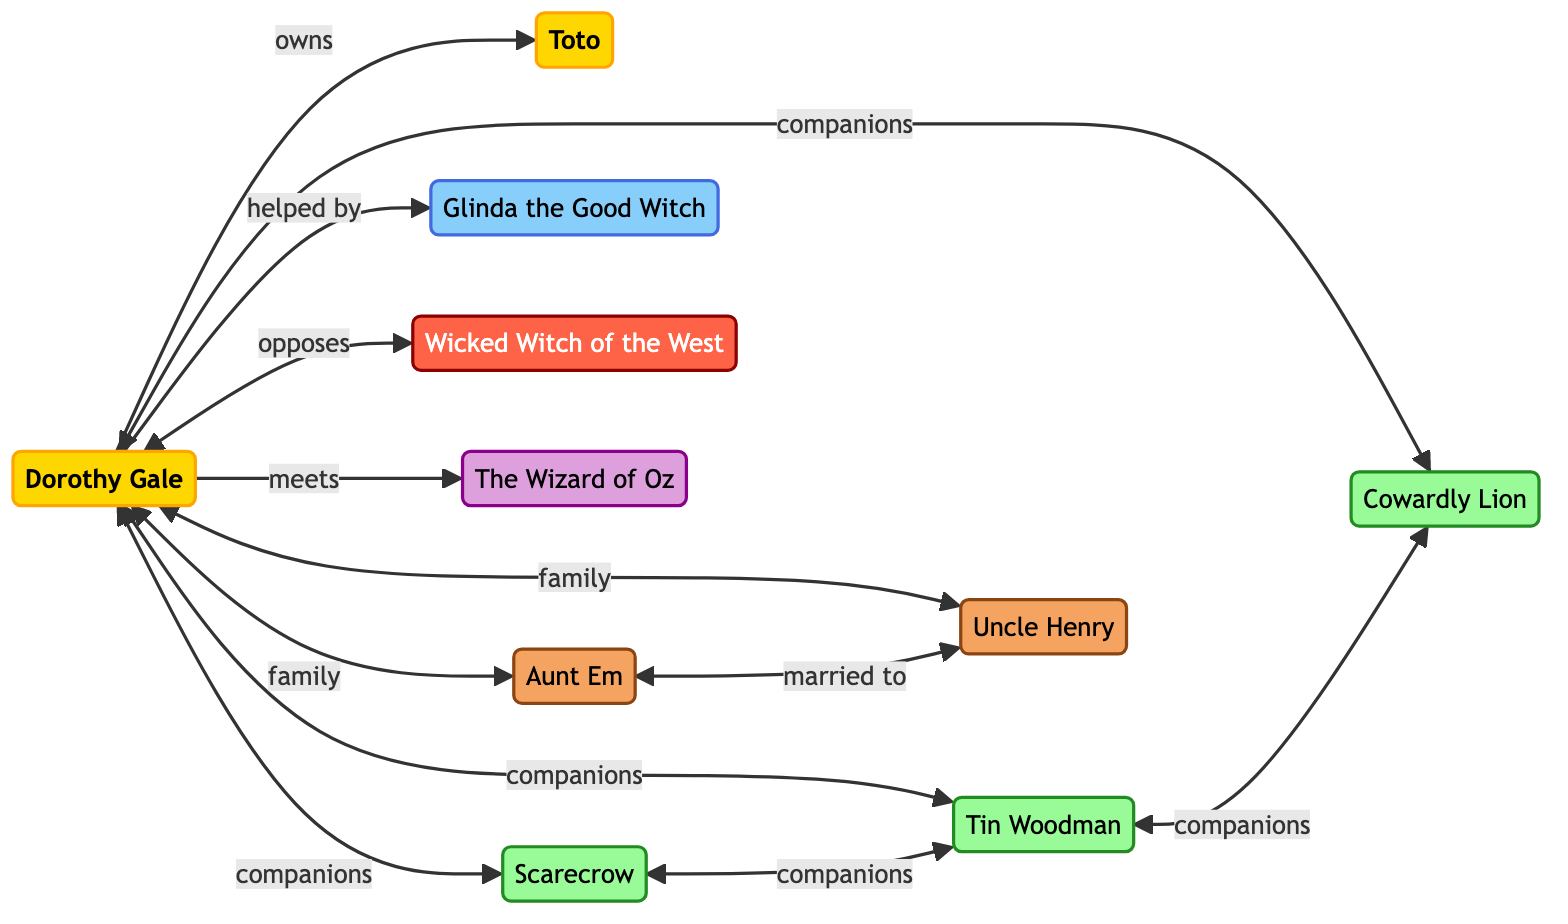What are the groups of the characters in the diagram? The diagram categorizes characters into groups: Protagonists, Companions, Allies, Antagonists, Others, and Kansas.
Answer: Protagonists, Companions, Allies, Antagonists, Others, Kansas How many companions does Dorothy Gale have? Dorothy has three companions in the diagram: Scarecrow, Tin Woodman, and Cowardly Lion.
Answer: 3 Who opposes Dorothy Gale? The diagram shows that the Wicked Witch of the West opposes Dorothy Gale.
Answer: Wicked Witch of the West What is the relationship between Aunt Em and Uncle Henry? In the diagram, Aunt Em is married to Uncle Henry, indicating a family relationship.
Answer: married to How many nodes are categorized as Allies? The diagram includes one character in the Allies’ group, which is Glinda the Good Witch.
Answer: 1 Which character does Dorothy Gale own? According to the diagram, Dorothy Gale owns Toto.
Answer: Toto Which two companions are directly connected to the Scarecrow? The diagram shows that the Scarecrow is directly connected to the Tin Woodman and the Cowardly Lion as companions.
Answer: Tin Woodman, Cowardly Lion Do any of Dorothy's companions also help her? The diagram indicates that Glinda the Good Witch helps Dorothy, but she is not a companion. Therefore, none of the companions help directly according to this diagram.
Answer: No Which character meets Dorothy Gale? The diagram notes that Dorothy Gale meets the Wizard of Oz.
Answer: The Wizard of Oz 